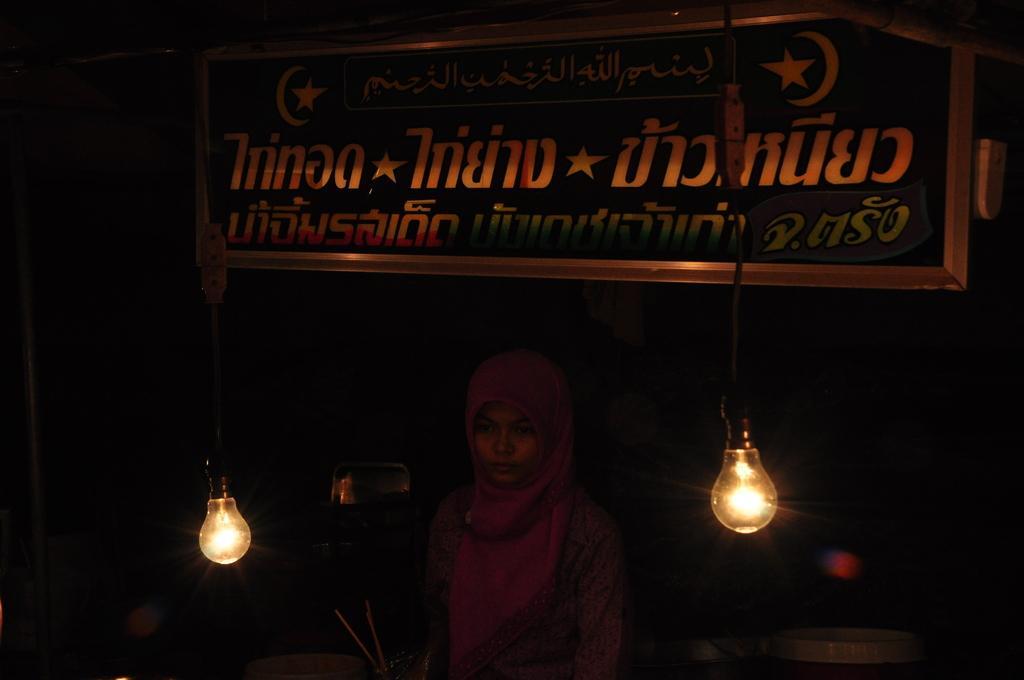Please provide a concise description of this image. In this image, we can see a person and a board with some text. We can also see some lights hanging. We can also see the dark background. 